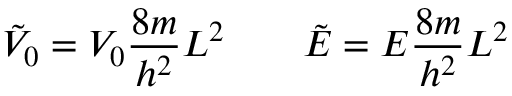Convert formula to latex. <formula><loc_0><loc_0><loc_500><loc_500>{ \tilde { V } } _ { 0 } = V _ { 0 } { \frac { 8 m } { h ^ { 2 } } } L ^ { 2 } \quad { \tilde { E } } = E { \frac { 8 m } { h ^ { 2 } } } L ^ { 2 }</formula> 